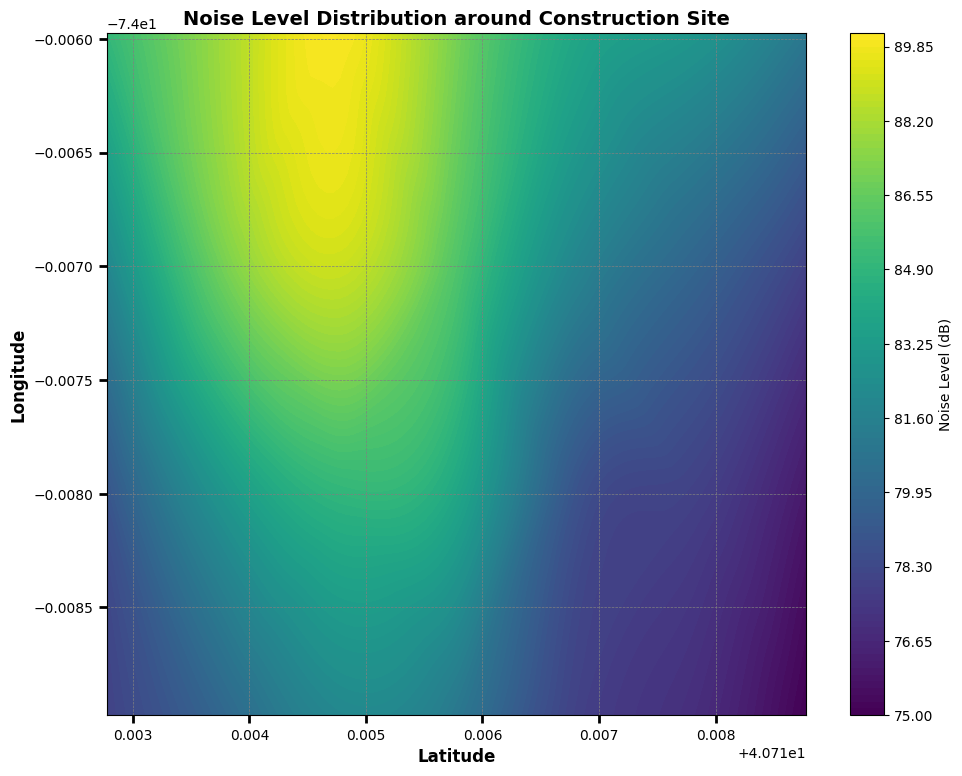what is the highest noise level in the central region of the map? To find the highest noise level in the central region, identify the portion of the contour plot that represents the middle area of the grid. Look for the area with the lightest color (representing the highest noise level) in this central region. The highest noise level in the central region appears to be 90 dB
Answer: 90 dB Which area has a lower noise level, the top left or the bottom right? Compare the noise levels in the top left and bottom right areas of the contour plot. The top left has higher intensity colors representing higher noise levels, while the bottom right has lower intensity colors. Thus, the bottom right has a lower noise level compared to the top left
Answer: bottom right How does the noise level change as you move from the bottom left to the top right of the map? Observe the color gradient as you move diagonally from the bottom left to the top right. Initially, the noise levels are lower (darker colors), and they increase as you move to the top left but decrease again as you reach the top right. Overall, there is an increase followed by a decrease
Answer: increase then decrease Are there any regions on the map where the noise level exceeds 85 dB? Look for areas in the contour plot with colors that correspond to noise levels above 85 dB. The top left region has the highest concentration of light colors, indicating noise levels above 85 dB
Answer: yes Compare the noise levels along the northern boundary of the map to the southern boundary. Which is higher on average? Examine the noise level colors along the top (northern) boundary and the bottom (southern) boundary. The top border shows higher intensity colors (lighter), implying higher noise levels compared to the bottom border, which shows darker colors. Therefore, the noise levels on the northern boundary are higher on average
Answer: northern boundary What is the average noise level in the western region of the map? To calculate the average noise level in the western region, approximate the noise levels from the contour colors in the leftmost part of the grid. Identify the values and average them: for instance, 85, 88, 90, 87, 84, 83, 81 from top to bottom, yielding an average of around 85 dB
Answer: 85 dB In which specific direction do the noise levels decrease most rapidly? Identify the direction that has the sharpest color transition from lightest to darkest. It appears that moving from north to south (top to bottom) results in the most rapid decrease in noise levels
Answer: north to south 